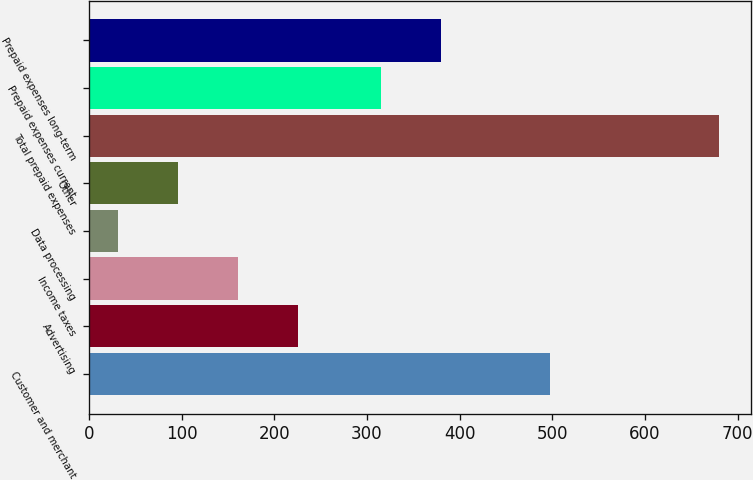<chart> <loc_0><loc_0><loc_500><loc_500><bar_chart><fcel>Customer and merchant<fcel>Advertising<fcel>Income taxes<fcel>Data processing<fcel>Other<fcel>Total prepaid expenses<fcel>Prepaid expenses current<fcel>Prepaid expenses long-term<nl><fcel>497<fcel>225.7<fcel>160.8<fcel>31<fcel>95.9<fcel>680<fcel>315<fcel>379.9<nl></chart> 